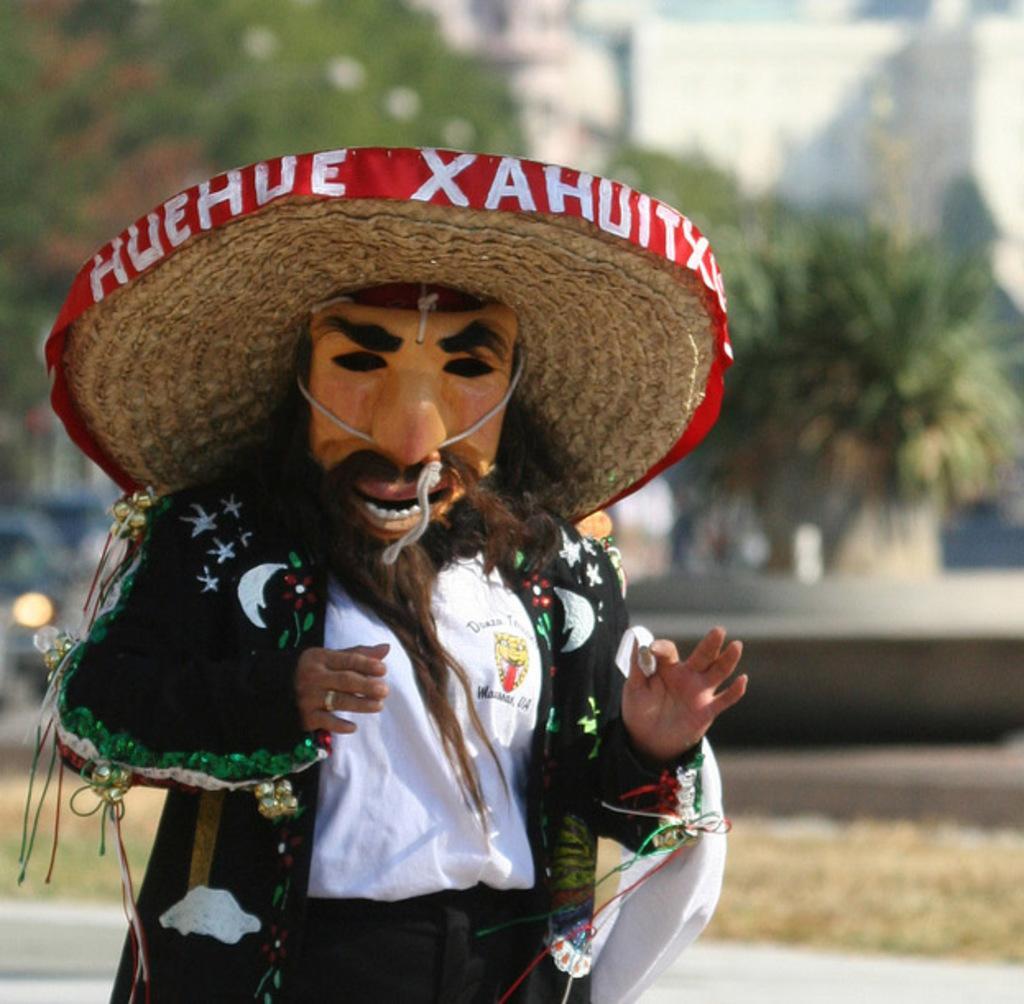Please provide a concise description of this image. In the picture I can see a person with a mask on the face and the person is on the left side. In the background, I can see the trees. 